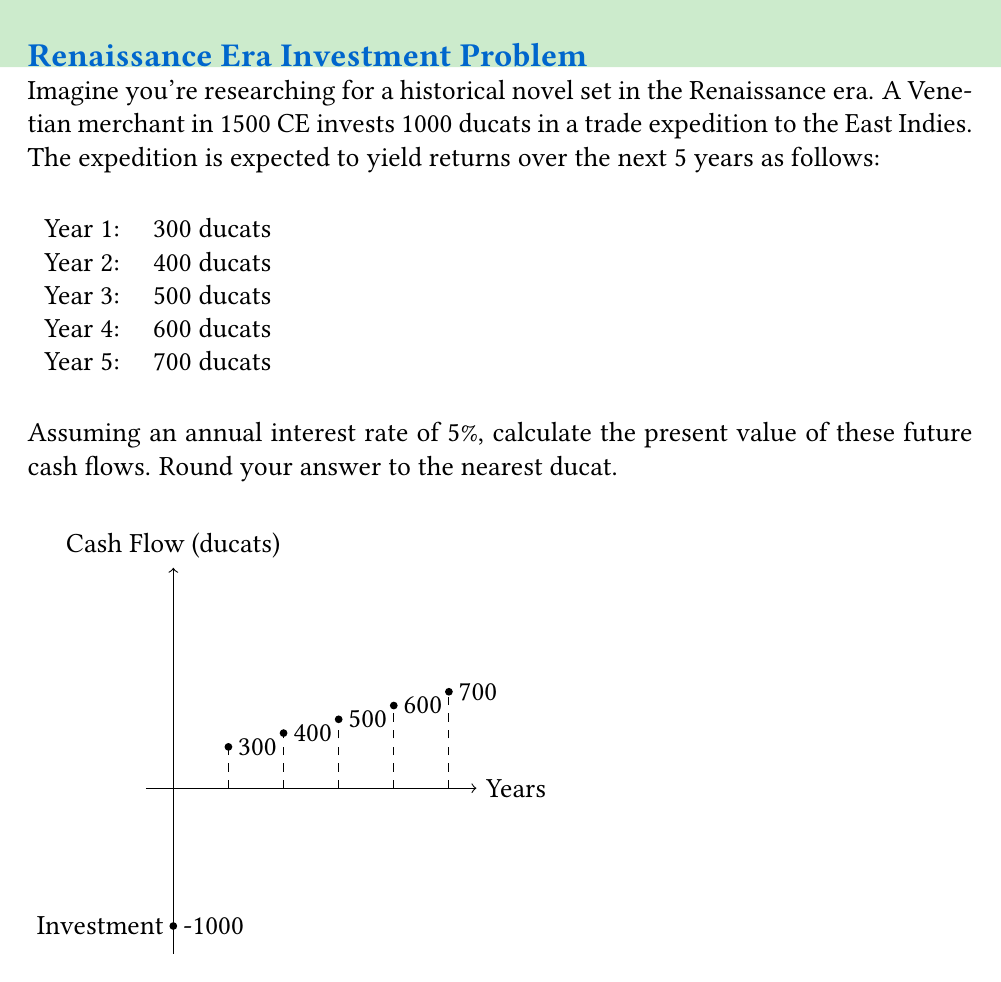Provide a solution to this math problem. To calculate the present value of future cash flows, we need to discount each cash flow back to the present using the given interest rate. The formula for present value is:

$$PV = \frac{CF_t}{(1+r)^t}$$

Where:
$PV$ = Present Value
$CF_t$ = Cash Flow at time t
$r$ = Interest rate
$t$ = Time period

Let's calculate the present value for each year:

Year 1: $PV_1 = \frac{300}{(1+0.05)^1} = 285.71$

Year 2: $PV_2 = \frac{400}{(1+0.05)^2} = 362.25$

Year 3: $PV_3 = \frac{500}{(1+0.05)^3} = 431.92$

Year 4: $PV_4 = \frac{600}{(1+0.05)^4} = 494.48$

Year 5: $PV_5 = \frac{700}{(1+0.05)^5} = 548.47$

Now, we sum up all these present values:

$Total PV = 285.71 + 362.25 + 431.92 + 494.48 + 548.47 = 2122.83$

Rounding to the nearest ducat, we get 2123 ducats.
Answer: 2123 ducats 